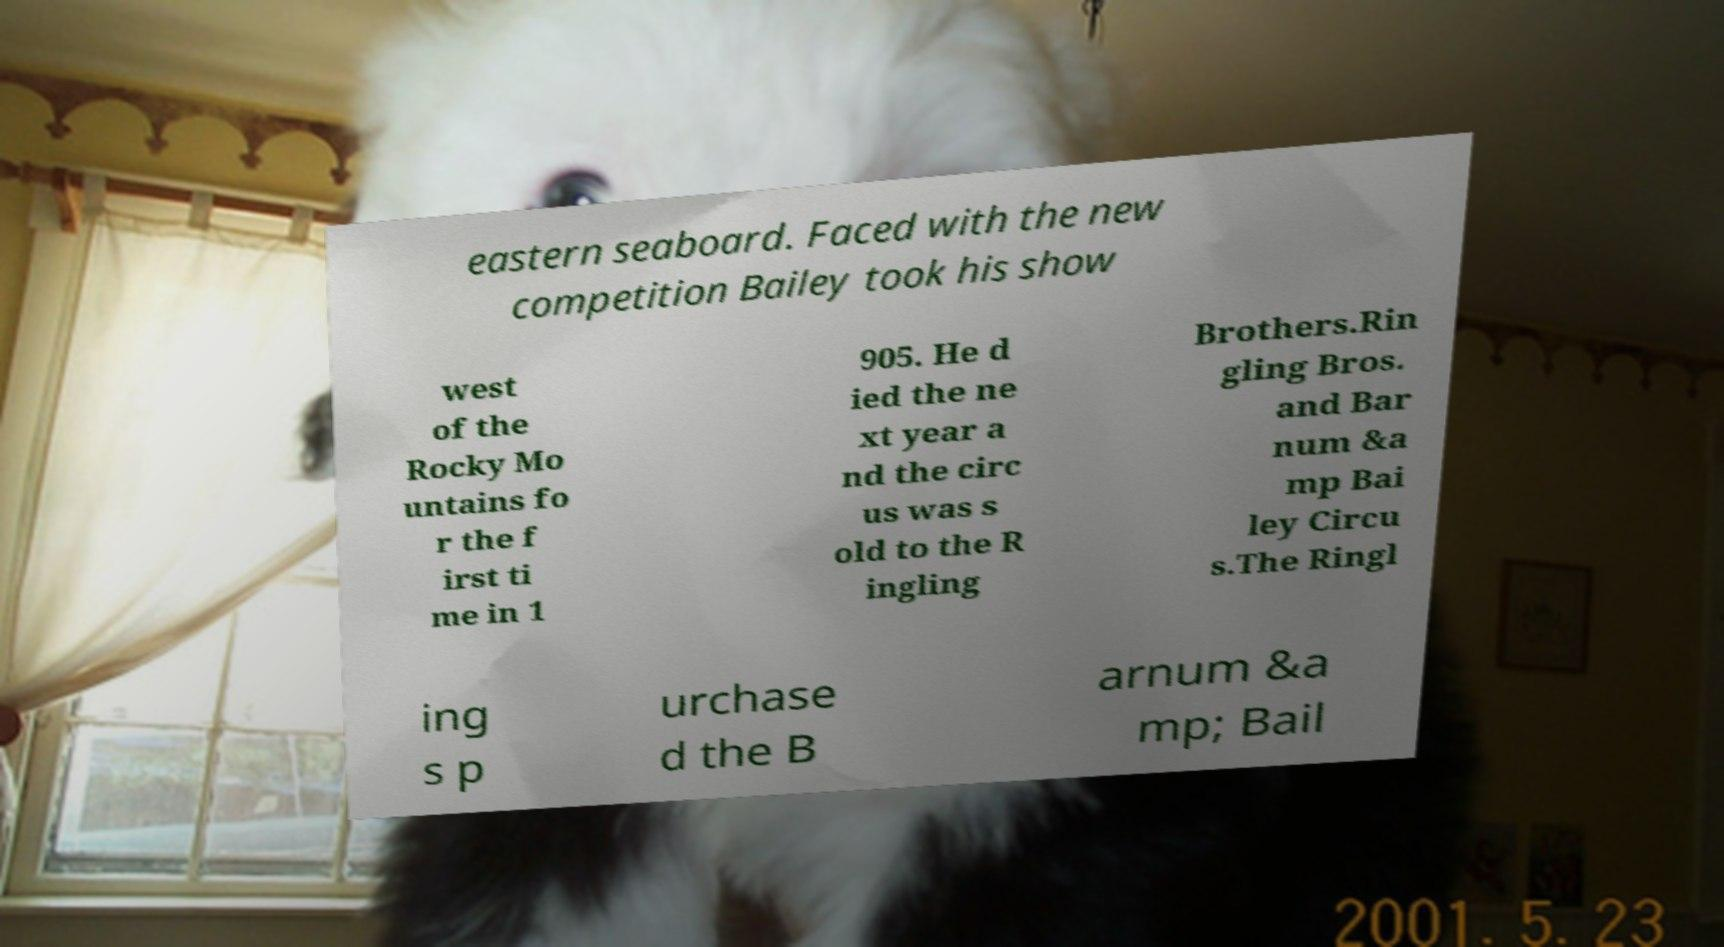I need the written content from this picture converted into text. Can you do that? eastern seaboard. Faced with the new competition Bailey took his show west of the Rocky Mo untains fo r the f irst ti me in 1 905. He d ied the ne xt year a nd the circ us was s old to the R ingling Brothers.Rin gling Bros. and Bar num &a mp Bai ley Circu s.The Ringl ing s p urchase d the B arnum &a mp; Bail 